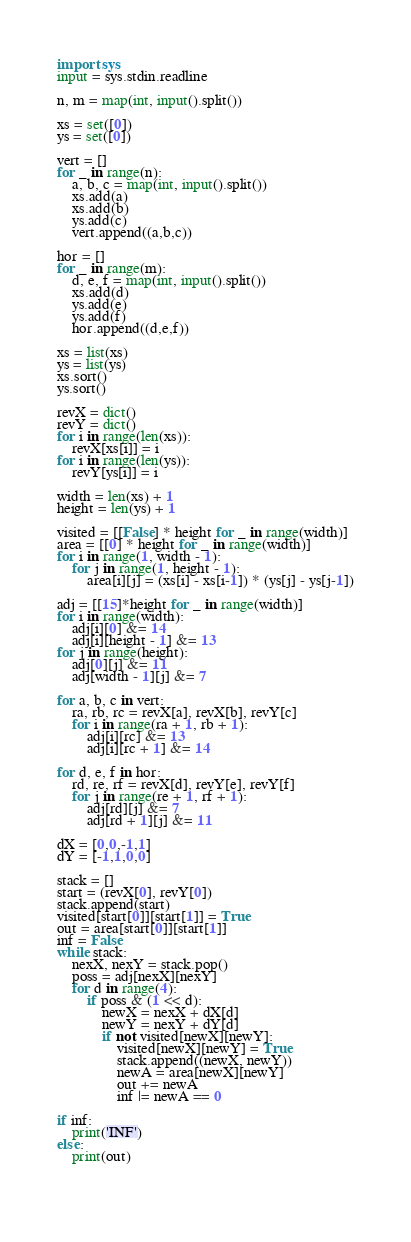Convert code to text. <code><loc_0><loc_0><loc_500><loc_500><_Python_>import sys
input = sys.stdin.readline

n, m = map(int, input().split())

xs = set([0])
ys = set([0])

vert = []
for _ in range(n):
    a, b, c = map(int, input().split())
    xs.add(a)
    xs.add(b)
    ys.add(c)
    vert.append((a,b,c))

hor = []
for _ in range(m):
    d, e, f = map(int, input().split())
    xs.add(d)
    ys.add(e)
    ys.add(f)
    hor.append((d,e,f))

xs = list(xs)
ys = list(ys)
xs.sort()
ys.sort()

revX = dict()
revY = dict()
for i in range(len(xs)):
    revX[xs[i]] = i
for i in range(len(ys)):
    revY[ys[i]] = i

width = len(xs) + 1
height = len(ys) + 1

visited = [[False] * height for _ in range(width)]
area = [[0] * height for _ in range(width)]
for i in range(1, width - 1):
    for j in range(1, height - 1):
        area[i][j] = (xs[i] - xs[i-1]) * (ys[j] - ys[j-1])
        
adj = [[15]*height for _ in range(width)]
for i in range(width):
    adj[i][0] &= 14
    adj[i][height - 1] &= 13
for j in range(height):
    adj[0][j] &= 11
    adj[width - 1][j] &= 7

for a, b, c in vert:
    ra, rb, rc = revX[a], revX[b], revY[c]
    for i in range(ra + 1, rb + 1):
        adj[i][rc] &= 13
        adj[i][rc + 1] &= 14

for d, e, f in hor:
    rd, re, rf = revX[d], revY[e], revY[f]
    for j in range(re + 1, rf + 1):
        adj[rd][j] &= 7
        adj[rd + 1][j] &= 11

dX = [0,0,-1,1]
dY = [-1,1,0,0]

stack = []
start = (revX[0], revY[0])
stack.append(start)
visited[start[0]][start[1]] = True
out = area[start[0]][start[1]]
inf = False
while stack:
    nexX, nexY = stack.pop()
    poss = adj[nexX][nexY]
    for d in range(4):
        if poss & (1 << d):
            newX = nexX + dX[d]
            newY = nexY + dY[d]
            if not visited[newX][newY]:
                visited[newX][newY] = True
                stack.append((newX, newY))
                newA = area[newX][newY]
                out += newA
                inf |= newA == 0

if inf:
    print('INF')
else:
    print(out)
            
        
</code> 